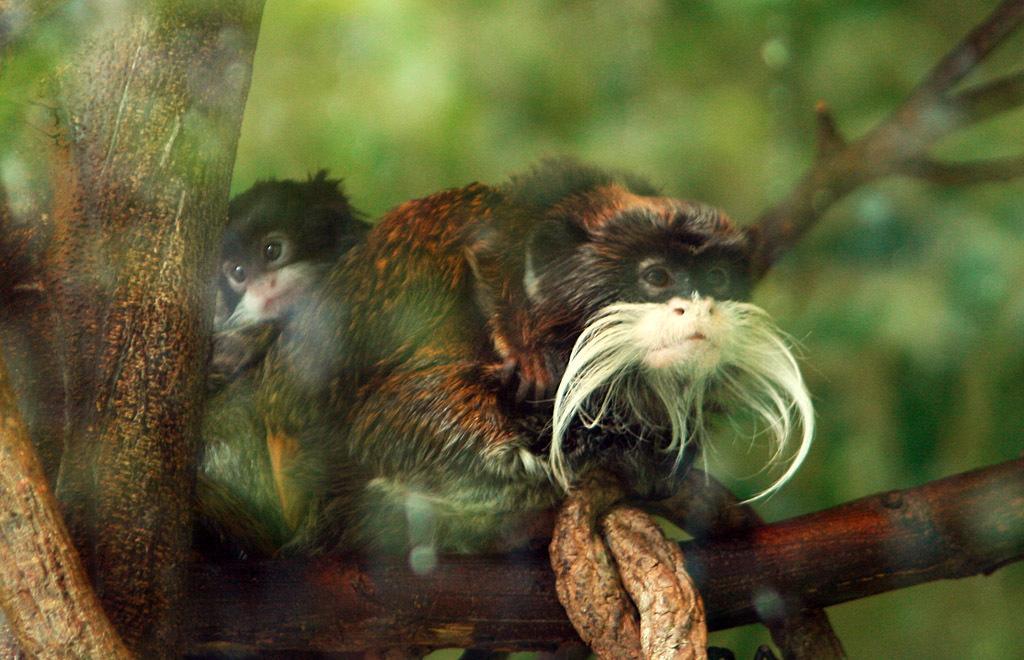How would you summarize this image in a sentence or two? In this image in front there are two bearded monkeys on the branch and the background of the image is blur. 